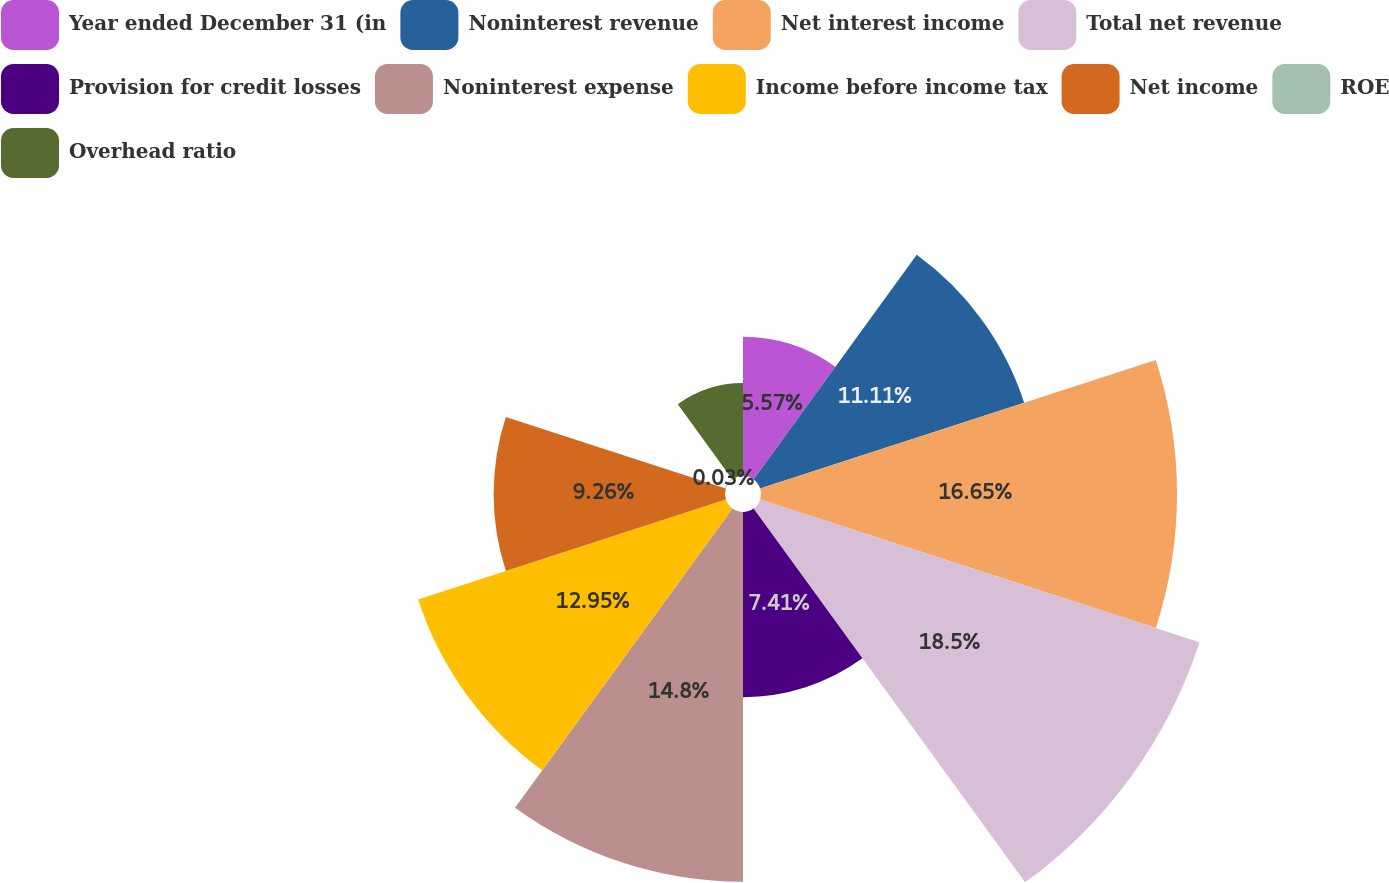<chart> <loc_0><loc_0><loc_500><loc_500><pie_chart><fcel>Year ended December 31 (in<fcel>Noninterest revenue<fcel>Net interest income<fcel>Total net revenue<fcel>Provision for credit losses<fcel>Noninterest expense<fcel>Income before income tax<fcel>Net income<fcel>ROE<fcel>Overhead ratio<nl><fcel>5.57%<fcel>11.11%<fcel>16.65%<fcel>18.49%<fcel>7.41%<fcel>14.8%<fcel>12.95%<fcel>9.26%<fcel>0.03%<fcel>3.72%<nl></chart> 